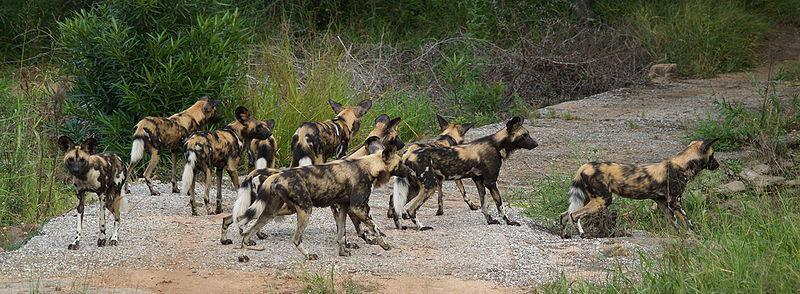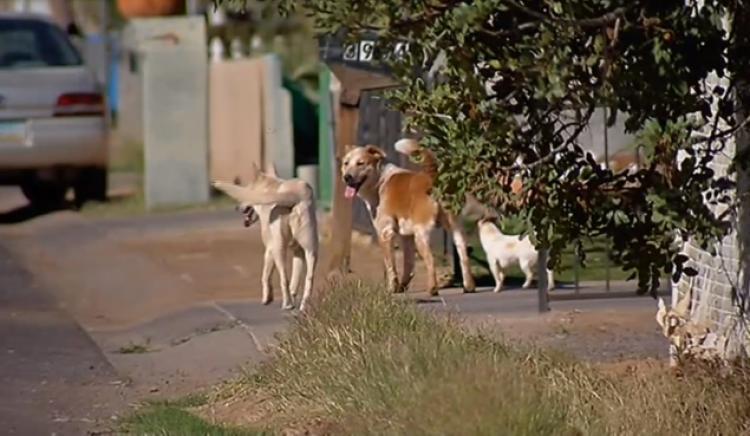The first image is the image on the left, the second image is the image on the right. For the images displayed, is the sentence "There is exactly one animal in one of the images." factually correct? Answer yes or no. No. 